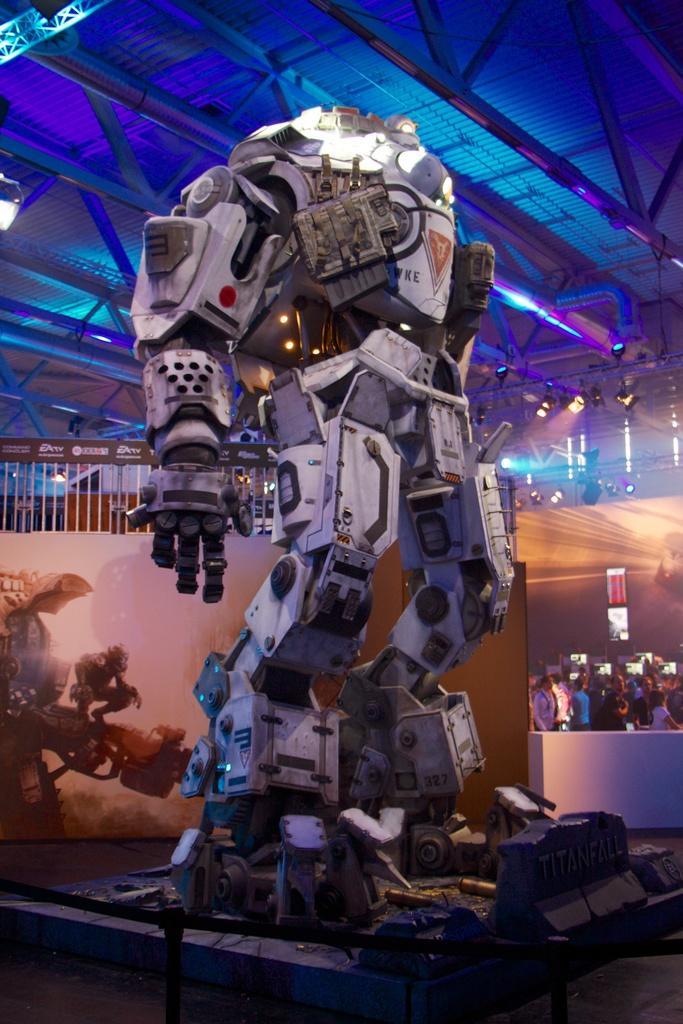Could you give a brief overview of what you see in this image? In the image there is a robot kept for an expo,behind the robot there is a huge crowd and there is a blue color light fit to the roof. 